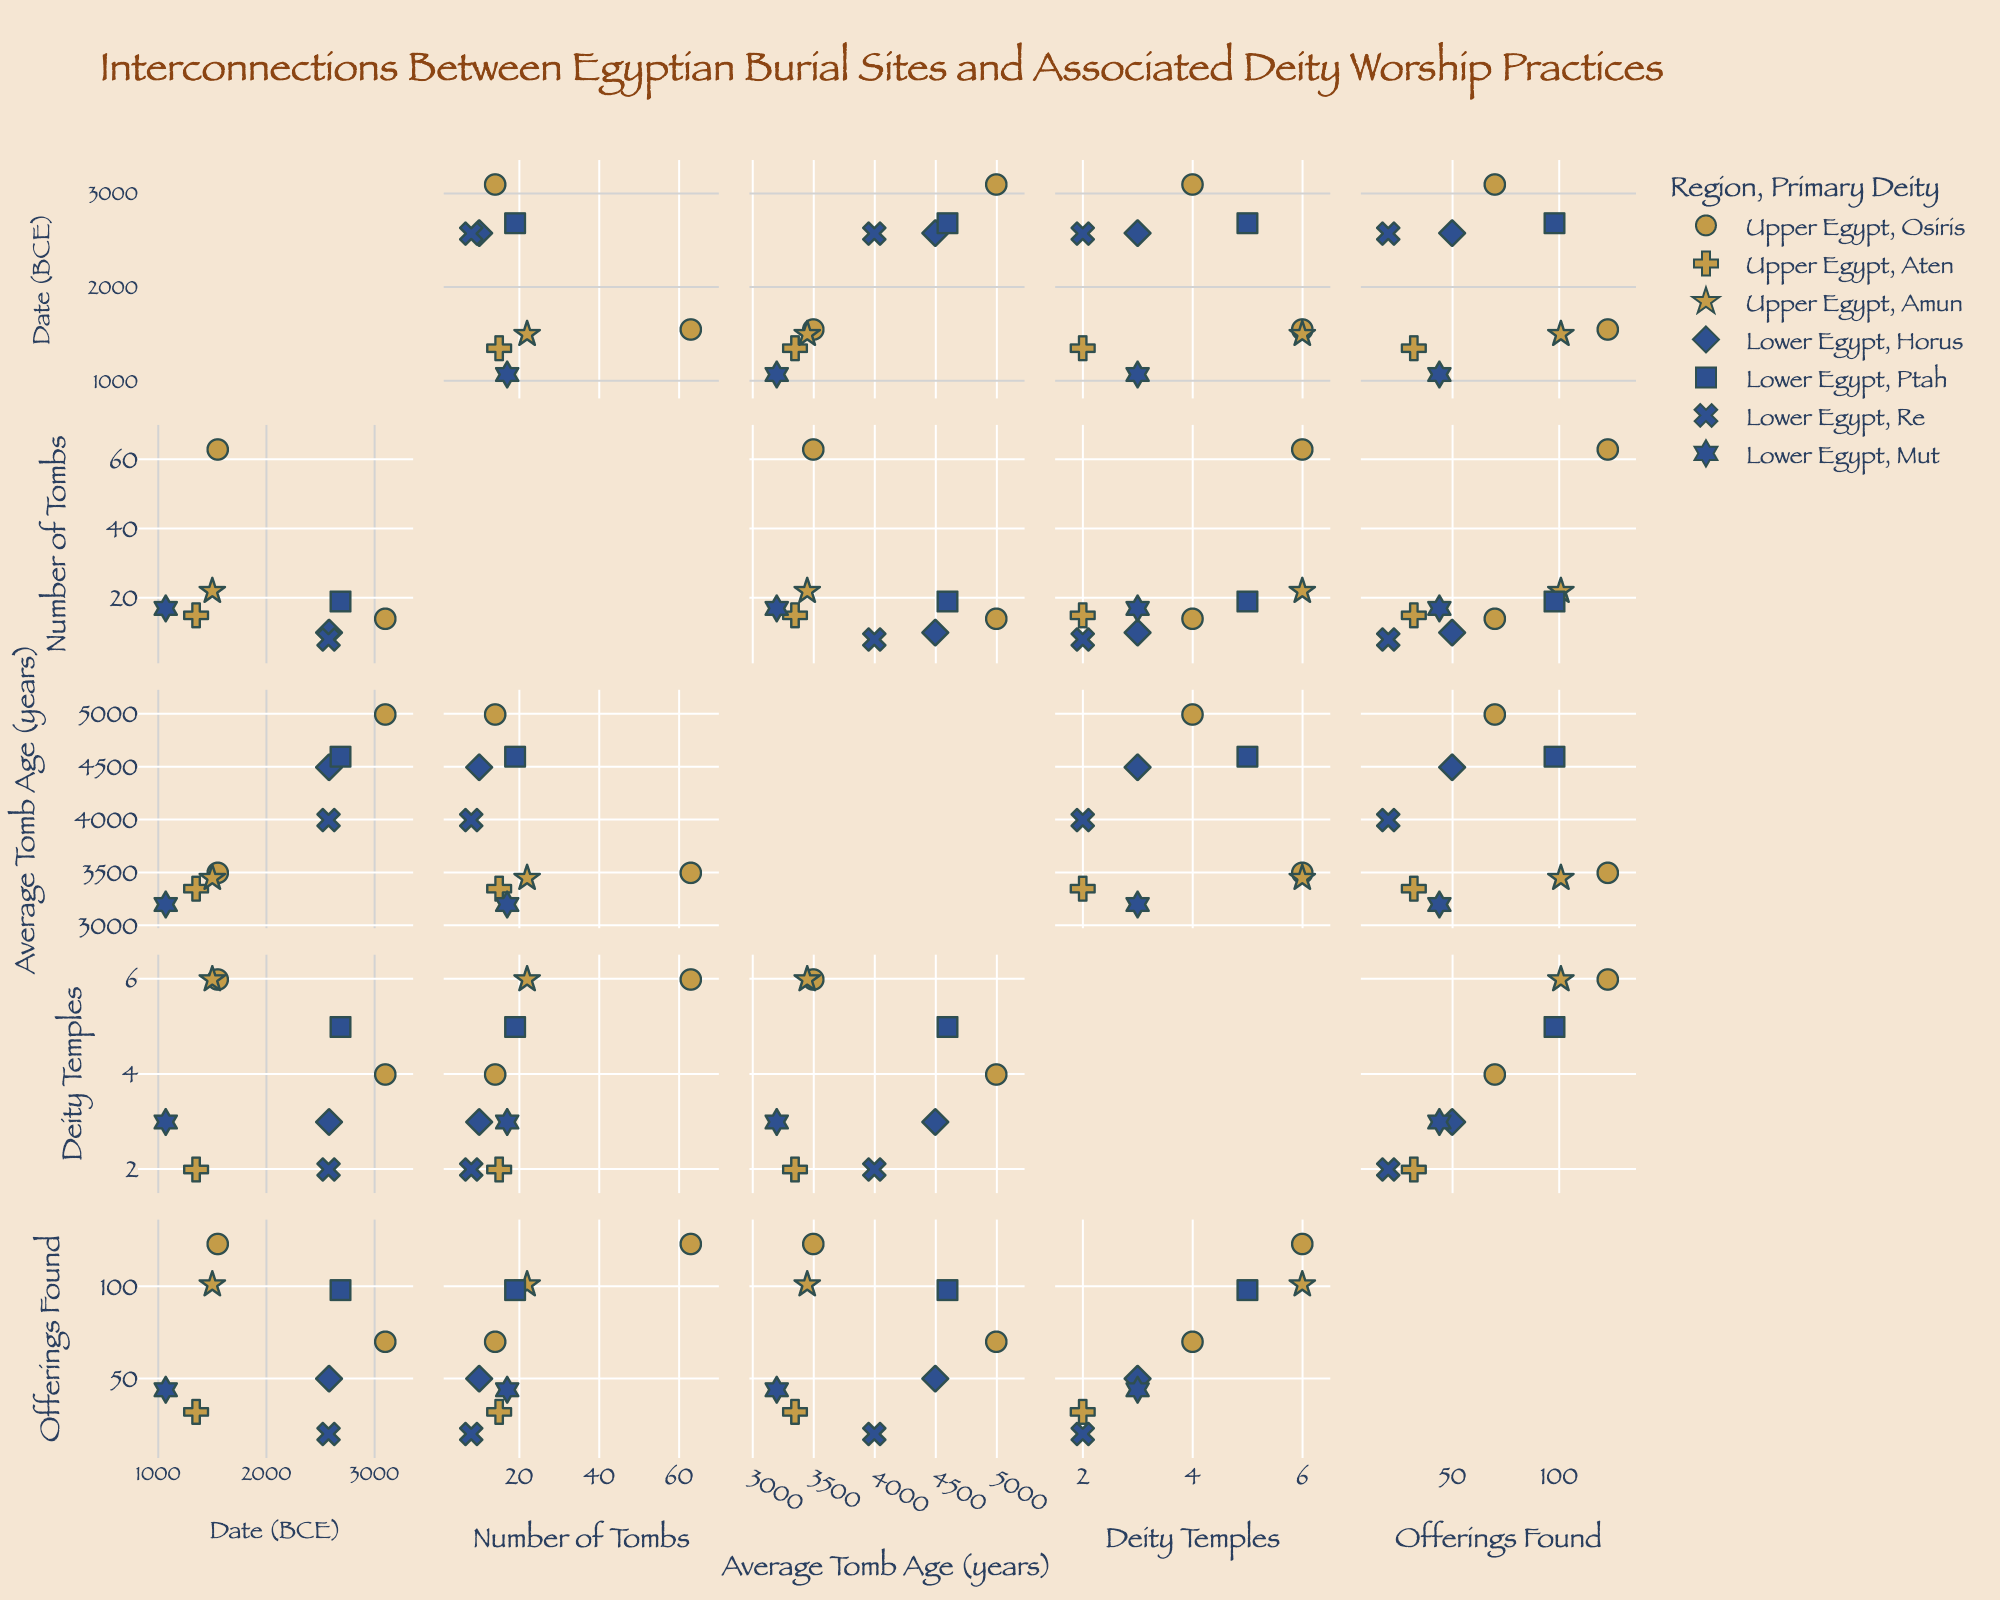What's the title of the figure? The title is prominently displayed at the top of the scatter plot matrix.
Answer: Interconnections Between Egyptian Burial Sites and Associated Deity Worship Practices How are the regions differentiated in the scatter plot matrix? The regions are differentiated by different colors in the scatter plot matrix. Upper Egypt is represented by a specific color, and Lower Egypt by another.
Answer: Upper Egypt (brown), Lower Egypt (blue) Which primary deity is represented by a hexagram symbol? Each primary deity is represented by a different symbol. By examining the legend, we can see that the hexagram symbol is used for the deity Mut.
Answer: Mut How many tombs are there in total across all presented sites? To find the total number of tombs, sum the "Number of Tombs" across all sites. Total = 63 (Valley of the Kings) + 10 (Giza Plateau) + 19 (Saqqara) + 14 (Abydos) + 15 (Amarna) + 8 (Dashur) + 22 (Luxor) + 17 (Tanis).
Answer: 168 Which site has the oldest average tomb age? By comparing the "Average Tomb Age (years)" across sites, Abydos has the oldest average tomb age of 5000 years.
Answer: Abydos How many deity temples are associated with the site in Lower Egypt that has the highest number of offerings found? In sites located in Lower Egypt, we compare the number of offerings found. Giza Plateau has 50, Saqqara has 98, Dashur has 20, and Tanis has 44. Saqqara has the highest with 98 offerings. The corresponding deity temples are 5.
Answer: 5 Which site in Upper Egypt has the fewest deity temples? Reviewing the number of deity temples among the sites in Upper Egypt, Amarna has the fewest with 2 temples.
Answer: Amarna Compare the total number of offerings found in Upper Egypt to that in Lower Egypt. Sum the "Offerings Found" for Upper Egypt sites and then for Lower Egypt sites. Upper Egypt: 123 + 70 + 32 + 101 = 326. Lower Egypt: 50 + 98 + 20 + 44 = 212. Compare the totals.
Answer: Upper Egypt: 326, Lower Egypt: 212 Is there any correlation between the average tomb age and the number of deity temples? Examine the scatter plots that plot "Average Tomb Age (years)" against "Deity Temples" for any visible trends or patterns. Correlation implies a consistent, visible trend or pattern throughout the data points.
Answer: No clear correlation Which deity has the most associated tombs, and what are the associated sites? Sum the "Number of Tombs" for each deity. Osiris: Valley of the Kings (63) + Abydos (14) = 77. Compare the tomb numbers for Horus, Ptah, Aten, Re, Amun, and Mut. Osiris has the most. The associated sites are Valley of the Kings and Abydos.
Answer: Osiris, Valley of the Kings and Abydos 